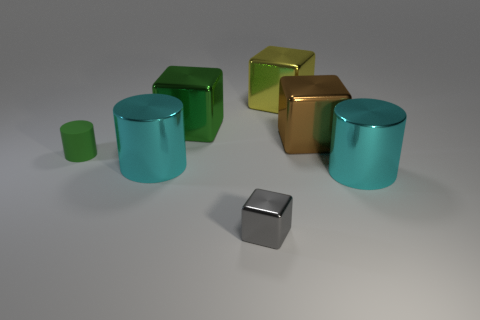How many other objects are the same size as the yellow object? 4 